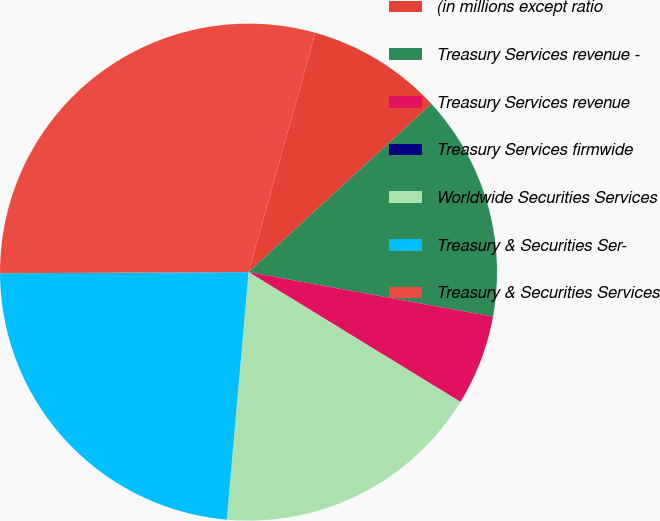Convert chart. <chart><loc_0><loc_0><loc_500><loc_500><pie_chart><fcel>(in millions except ratio<fcel>Treasury Services revenue -<fcel>Treasury Services revenue<fcel>Treasury Services firmwide<fcel>Worldwide Securities Services<fcel>Treasury & Securities Ser-<fcel>Treasury & Securities Services<nl><fcel>8.82%<fcel>14.71%<fcel>5.88%<fcel>0.0%<fcel>17.65%<fcel>23.53%<fcel>29.41%<nl></chart> 